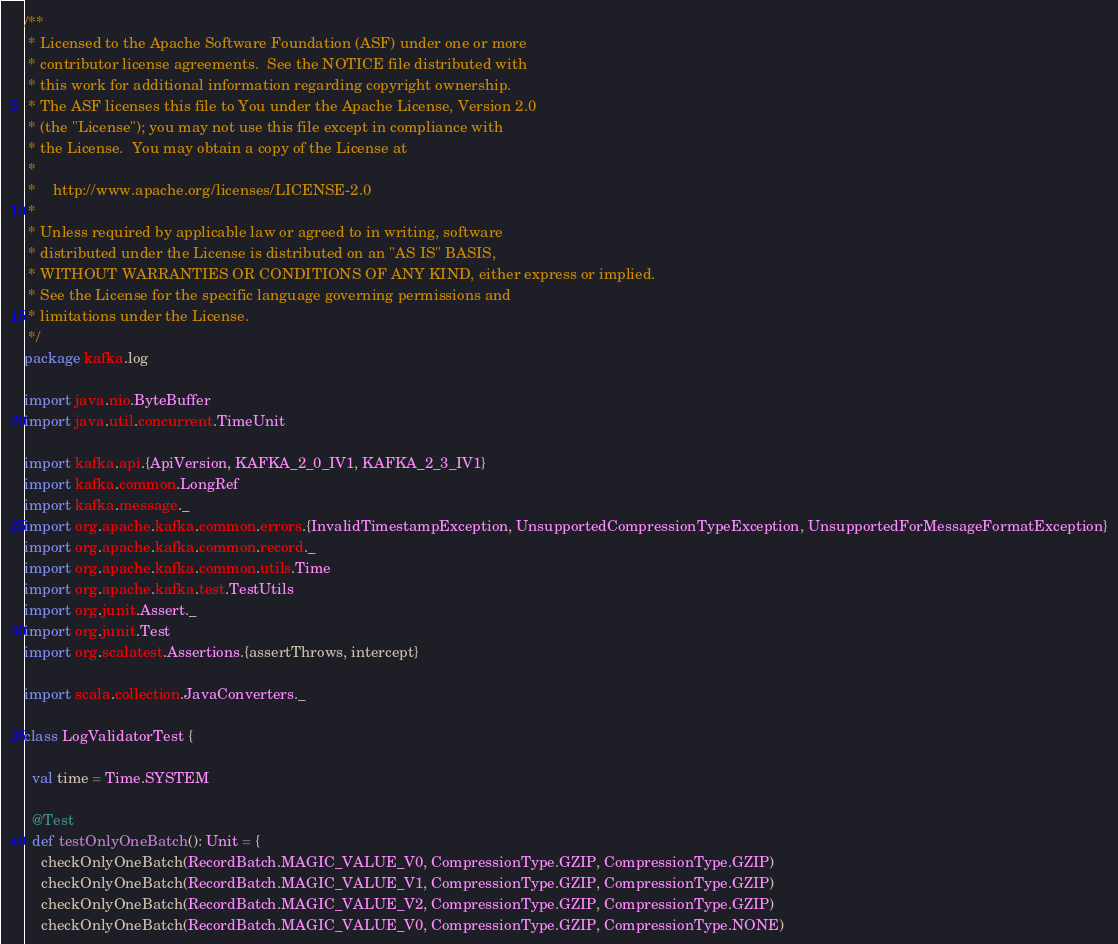<code> <loc_0><loc_0><loc_500><loc_500><_Scala_>/**
 * Licensed to the Apache Software Foundation (ASF) under one or more
 * contributor license agreements.  See the NOTICE file distributed with
 * this work for additional information regarding copyright ownership.
 * The ASF licenses this file to You under the Apache License, Version 2.0
 * (the "License"); you may not use this file except in compliance with
 * the License.  You may obtain a copy of the License at
 *
 *    http://www.apache.org/licenses/LICENSE-2.0
 *
 * Unless required by applicable law or agreed to in writing, software
 * distributed under the License is distributed on an "AS IS" BASIS,
 * WITHOUT WARRANTIES OR CONDITIONS OF ANY KIND, either express or implied.
 * See the License for the specific language governing permissions and
 * limitations under the License.
 */
package kafka.log

import java.nio.ByteBuffer
import java.util.concurrent.TimeUnit

import kafka.api.{ApiVersion, KAFKA_2_0_IV1, KAFKA_2_3_IV1}
import kafka.common.LongRef
import kafka.message._
import org.apache.kafka.common.errors.{InvalidTimestampException, UnsupportedCompressionTypeException, UnsupportedForMessageFormatException}
import org.apache.kafka.common.record._
import org.apache.kafka.common.utils.Time
import org.apache.kafka.test.TestUtils
import org.junit.Assert._
import org.junit.Test
import org.scalatest.Assertions.{assertThrows, intercept}

import scala.collection.JavaConverters._

class LogValidatorTest {

  val time = Time.SYSTEM

  @Test
  def testOnlyOneBatch(): Unit = {
    checkOnlyOneBatch(RecordBatch.MAGIC_VALUE_V0, CompressionType.GZIP, CompressionType.GZIP)
    checkOnlyOneBatch(RecordBatch.MAGIC_VALUE_V1, CompressionType.GZIP, CompressionType.GZIP)
    checkOnlyOneBatch(RecordBatch.MAGIC_VALUE_V2, CompressionType.GZIP, CompressionType.GZIP)
    checkOnlyOneBatch(RecordBatch.MAGIC_VALUE_V0, CompressionType.GZIP, CompressionType.NONE)</code> 